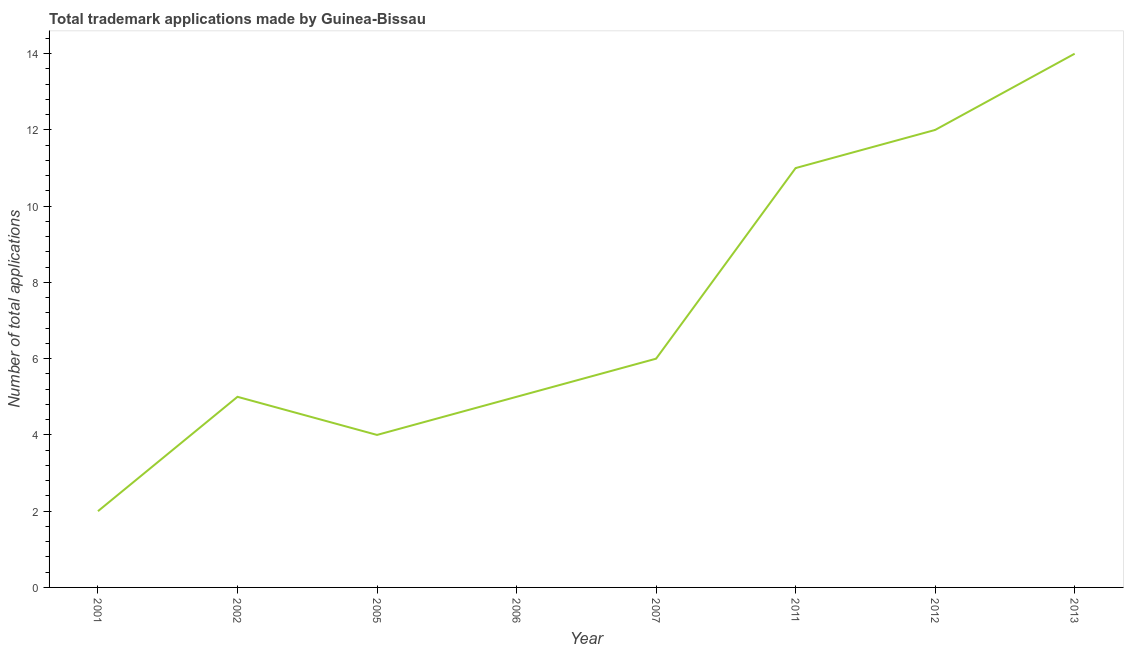What is the number of trademark applications in 2002?
Your response must be concise. 5. Across all years, what is the maximum number of trademark applications?
Your answer should be very brief. 14. Across all years, what is the minimum number of trademark applications?
Keep it short and to the point. 2. What is the sum of the number of trademark applications?
Your answer should be compact. 59. What is the difference between the number of trademark applications in 2001 and 2006?
Your response must be concise. -3. What is the average number of trademark applications per year?
Your answer should be compact. 7.38. What is the ratio of the number of trademark applications in 2007 to that in 2013?
Make the answer very short. 0.43. Is the number of trademark applications in 2001 less than that in 2011?
Your answer should be very brief. Yes. What is the difference between the highest and the second highest number of trademark applications?
Offer a very short reply. 2. Is the sum of the number of trademark applications in 2002 and 2006 greater than the maximum number of trademark applications across all years?
Your answer should be compact. No. What is the difference between the highest and the lowest number of trademark applications?
Offer a terse response. 12. Does the number of trademark applications monotonically increase over the years?
Ensure brevity in your answer.  No. How many years are there in the graph?
Offer a very short reply. 8. What is the difference between two consecutive major ticks on the Y-axis?
Offer a terse response. 2. Are the values on the major ticks of Y-axis written in scientific E-notation?
Provide a succinct answer. No. What is the title of the graph?
Give a very brief answer. Total trademark applications made by Guinea-Bissau. What is the label or title of the Y-axis?
Ensure brevity in your answer.  Number of total applications. What is the Number of total applications of 2001?
Provide a short and direct response. 2. What is the Number of total applications in 2002?
Your answer should be very brief. 5. What is the Number of total applications of 2006?
Provide a short and direct response. 5. What is the Number of total applications in 2007?
Provide a succinct answer. 6. What is the Number of total applications in 2011?
Your response must be concise. 11. What is the difference between the Number of total applications in 2001 and 2006?
Offer a terse response. -3. What is the difference between the Number of total applications in 2001 and 2011?
Your response must be concise. -9. What is the difference between the Number of total applications in 2001 and 2013?
Ensure brevity in your answer.  -12. What is the difference between the Number of total applications in 2002 and 2005?
Your answer should be compact. 1. What is the difference between the Number of total applications in 2002 and 2007?
Keep it short and to the point. -1. What is the difference between the Number of total applications in 2002 and 2011?
Your answer should be compact. -6. What is the difference between the Number of total applications in 2005 and 2012?
Your answer should be very brief. -8. What is the difference between the Number of total applications in 2005 and 2013?
Your answer should be compact. -10. What is the difference between the Number of total applications in 2006 and 2013?
Offer a very short reply. -9. What is the difference between the Number of total applications in 2011 and 2012?
Provide a short and direct response. -1. What is the difference between the Number of total applications in 2011 and 2013?
Provide a succinct answer. -3. What is the difference between the Number of total applications in 2012 and 2013?
Make the answer very short. -2. What is the ratio of the Number of total applications in 2001 to that in 2002?
Make the answer very short. 0.4. What is the ratio of the Number of total applications in 2001 to that in 2006?
Your answer should be compact. 0.4. What is the ratio of the Number of total applications in 2001 to that in 2007?
Give a very brief answer. 0.33. What is the ratio of the Number of total applications in 2001 to that in 2011?
Provide a short and direct response. 0.18. What is the ratio of the Number of total applications in 2001 to that in 2012?
Offer a terse response. 0.17. What is the ratio of the Number of total applications in 2001 to that in 2013?
Offer a terse response. 0.14. What is the ratio of the Number of total applications in 2002 to that in 2005?
Provide a succinct answer. 1.25. What is the ratio of the Number of total applications in 2002 to that in 2007?
Your answer should be compact. 0.83. What is the ratio of the Number of total applications in 2002 to that in 2011?
Offer a very short reply. 0.46. What is the ratio of the Number of total applications in 2002 to that in 2012?
Your answer should be very brief. 0.42. What is the ratio of the Number of total applications in 2002 to that in 2013?
Give a very brief answer. 0.36. What is the ratio of the Number of total applications in 2005 to that in 2007?
Keep it short and to the point. 0.67. What is the ratio of the Number of total applications in 2005 to that in 2011?
Your answer should be very brief. 0.36. What is the ratio of the Number of total applications in 2005 to that in 2012?
Make the answer very short. 0.33. What is the ratio of the Number of total applications in 2005 to that in 2013?
Your answer should be compact. 0.29. What is the ratio of the Number of total applications in 2006 to that in 2007?
Provide a succinct answer. 0.83. What is the ratio of the Number of total applications in 2006 to that in 2011?
Your response must be concise. 0.46. What is the ratio of the Number of total applications in 2006 to that in 2012?
Your answer should be very brief. 0.42. What is the ratio of the Number of total applications in 2006 to that in 2013?
Provide a short and direct response. 0.36. What is the ratio of the Number of total applications in 2007 to that in 2011?
Offer a terse response. 0.55. What is the ratio of the Number of total applications in 2007 to that in 2012?
Your answer should be very brief. 0.5. What is the ratio of the Number of total applications in 2007 to that in 2013?
Ensure brevity in your answer.  0.43. What is the ratio of the Number of total applications in 2011 to that in 2012?
Ensure brevity in your answer.  0.92. What is the ratio of the Number of total applications in 2011 to that in 2013?
Provide a short and direct response. 0.79. What is the ratio of the Number of total applications in 2012 to that in 2013?
Provide a succinct answer. 0.86. 